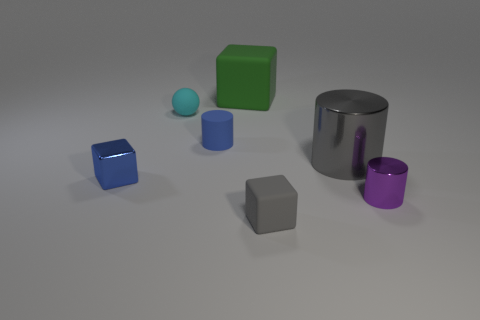Subtract all large green rubber blocks. How many blocks are left? 2 Add 1 small metal cylinders. How many objects exist? 8 Subtract 1 balls. How many balls are left? 0 Subtract all cylinders. How many objects are left? 4 Add 4 tiny rubber spheres. How many tiny rubber spheres exist? 5 Subtract all gray cylinders. How many cylinders are left? 2 Subtract 0 yellow balls. How many objects are left? 7 Subtract all red cubes. Subtract all blue balls. How many cubes are left? 3 Subtract all gray cylinders. How many gray balls are left? 0 Subtract all big green metal balls. Subtract all tiny spheres. How many objects are left? 6 